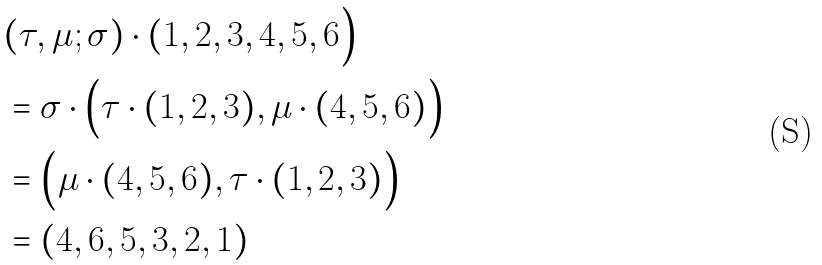<formula> <loc_0><loc_0><loc_500><loc_500>& ( \tau , \mu ; \sigma ) \cdot ( 1 , 2 , 3 , 4 , 5 , 6 \Big ) \\ & = \sigma \cdot \Big ( \tau \cdot ( 1 , 2 , 3 ) , \mu \cdot ( 4 , 5 , 6 ) \Big ) \\ & = \Big ( \mu \cdot ( 4 , 5 , 6 ) , \tau \cdot ( 1 , 2 , 3 ) \Big ) \\ & = ( 4 , 6 , 5 , 3 , 2 , 1 )</formula> 